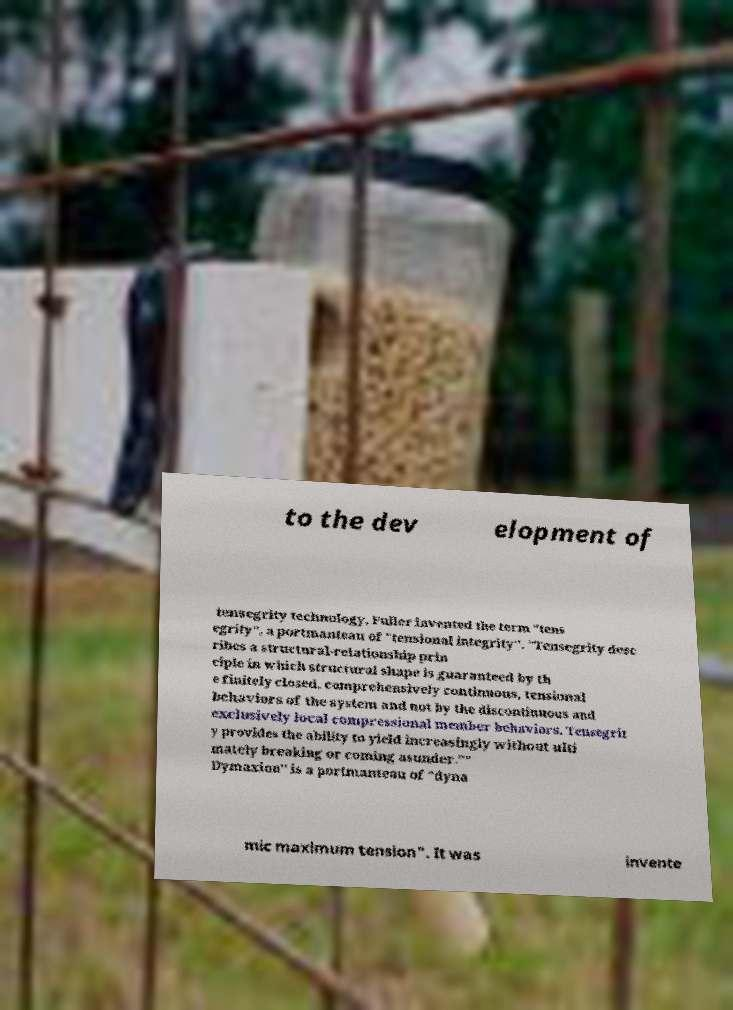Please identify and transcribe the text found in this image. to the dev elopment of tensegrity technology, Fuller invented the term "tens egrity", a portmanteau of "tensional integrity". "Tensegrity desc ribes a structural-relationship prin ciple in which structural shape is guaranteed by th e finitely closed, comprehensively continuous, tensional behaviors of the system and not by the discontinuous and exclusively local compressional member behaviors. Tensegrit y provides the ability to yield increasingly without ulti mately breaking or coming asunder."" Dymaxion" is a portmanteau of "dyna mic maximum tension". It was invente 